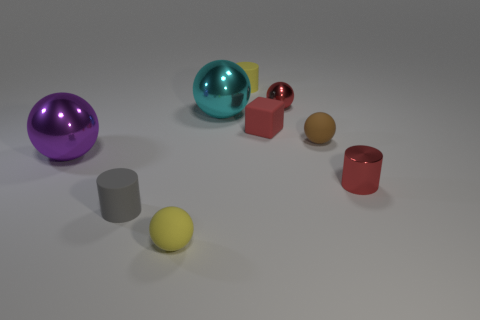What shape is the gray rubber thing that is the same size as the red rubber object? cylinder 